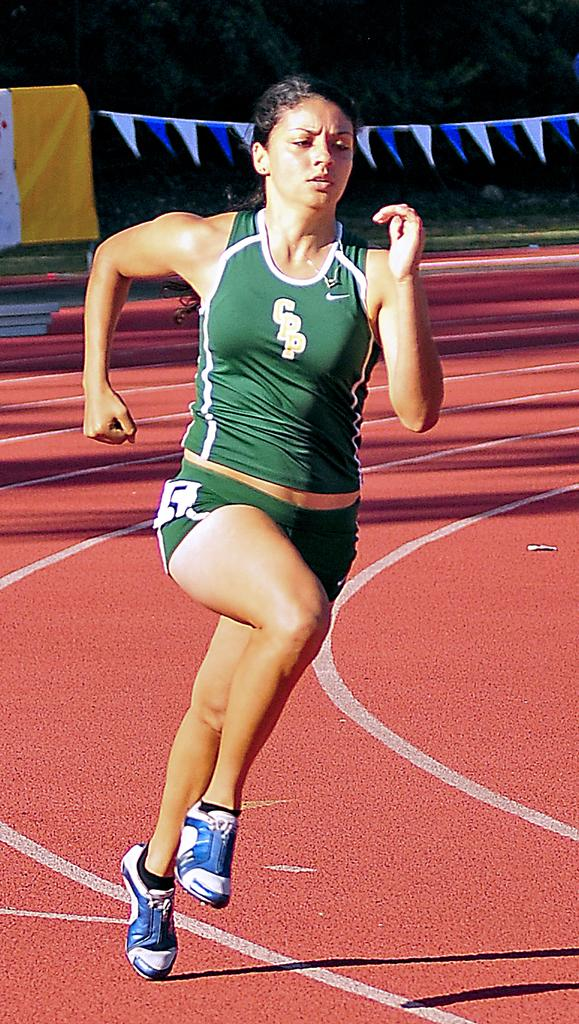Provide a one-sentence caption for the provided image. A track athlete for CPP is rounding the turn in a race. 